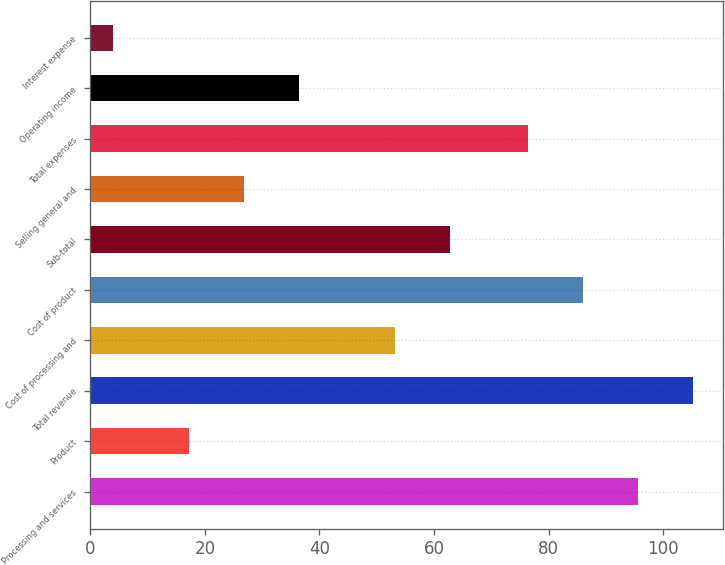Convert chart to OTSL. <chart><loc_0><loc_0><loc_500><loc_500><bar_chart><fcel>Processing and services<fcel>Product<fcel>Total revenue<fcel>Cost of processing and<fcel>Cost of product<fcel>Sub-total<fcel>Selling general and<fcel>Total expenses<fcel>Operating income<fcel>Interest expense<nl><fcel>95.62<fcel>17.2<fcel>105.23<fcel>53.1<fcel>86.01<fcel>62.71<fcel>26.81<fcel>76.4<fcel>36.42<fcel>3.9<nl></chart> 